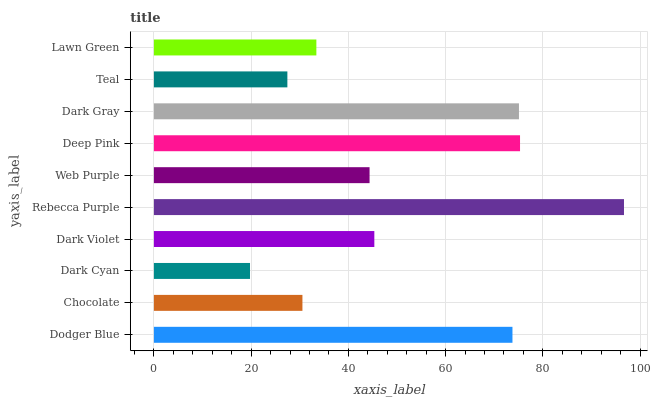Is Dark Cyan the minimum?
Answer yes or no. Yes. Is Rebecca Purple the maximum?
Answer yes or no. Yes. Is Chocolate the minimum?
Answer yes or no. No. Is Chocolate the maximum?
Answer yes or no. No. Is Dodger Blue greater than Chocolate?
Answer yes or no. Yes. Is Chocolate less than Dodger Blue?
Answer yes or no. Yes. Is Chocolate greater than Dodger Blue?
Answer yes or no. No. Is Dodger Blue less than Chocolate?
Answer yes or no. No. Is Dark Violet the high median?
Answer yes or no. Yes. Is Web Purple the low median?
Answer yes or no. Yes. Is Rebecca Purple the high median?
Answer yes or no. No. Is Dark Cyan the low median?
Answer yes or no. No. 